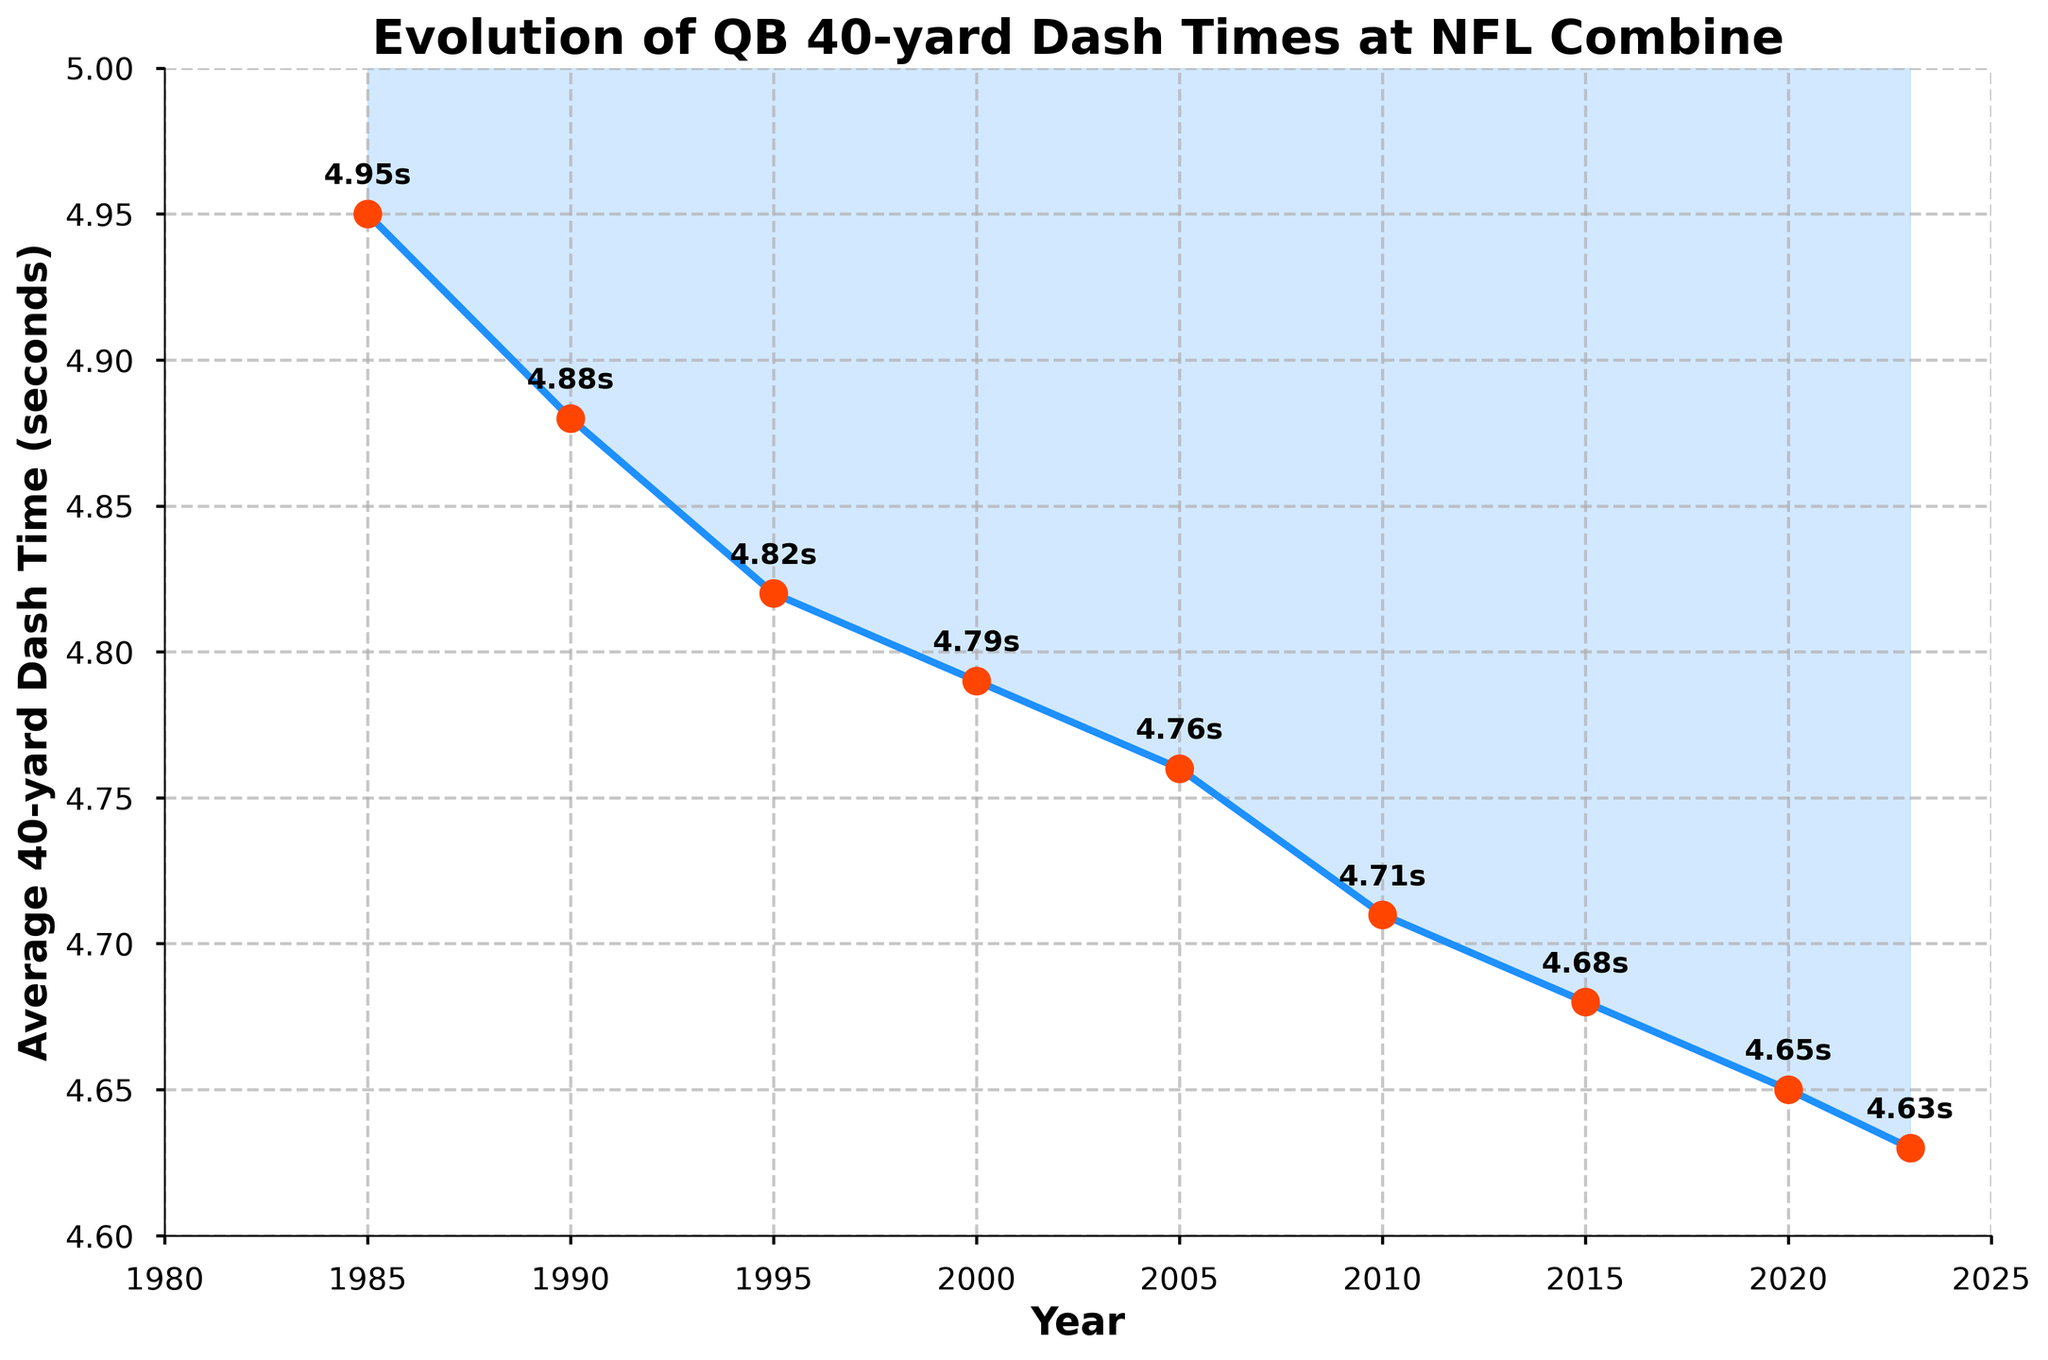What is the trend in quarterback 40-yard dash times from 1985 to 2023? Looking at the figure, the average 40-yard dash times have decreased from 4.95 seconds in 1985 to 4.63 seconds in 2023, indicating a gradual increase in speed over the years.
Answer: Decreasing trend Which year recorded the largest improvement in average 40-yard dash time compared to the previous recorded year? By examining the differences between consecutive years: 
1990-1985: 4.95-4.88 = 0.07 
1995-1990: 4.88-4.82 = 0.06 
2000-1995: 4.82-4.79 = 0.03 
2005-2000: 4.79-4.76 = 0.03 
2010-2005: 4.76-4.71 = 0.05 
2015-2010: 4.71-4.68 = 0.03 
2020-2015: 4.68-4.65 = 0.03 
2023-2020: 4.65-4.63 = 0.02 
So, the largest improvement was between 1985 and 1990 with a difference of 0.07 seconds.
Answer: 1990 How much faster were the quarterbacks on average in 2010 compared to 1985? By subtracting the 2010 time from the 1985 time: 4.95 - 4.71 = 0.24 seconds
Answer: 0.24 seconds What is the average (mean) of the average 40-yard dash times from all the years provided? Sum up all the dash times: 4.95 + 4.88 + 4.82 + 4.79 + 4.76 + 4.71 + 4.68 + 4.65 + 4.63 = 42.87, divide by the number of years, which is 9. 42.87 / 9 ≈ 4.763
Answer: 4.763 seconds In which time period did the average 40-yard dash times improve the most rapidly? From 1985 to 1995, the average times improved from 4.95 to 4.82, a 0.13-second improvement in 10 years (0.013 per year). From 1995 to 2023, they improved from 4.82 to 4.63, a 0.19-second improvement in 28 years (~0.0068 per year). That means the most rapid improvement was from 1985 to 1995.
Answer: 1985-1995 What is the difference in average 40-yard dash times between 1985 and 2023? Subtract the time in 2023 from the time in 1985: 4.95 - 4.63 = 0.32 seconds
Answer: 0.32 seconds Compare the average improvement in 40-yard dash times between the periods 2000-2010 and 2010-2020. Which period shows a greater average annual improvement? 1. Calculate the improvement for 2000-2010: 4.79 - 4.71 = 0.08 seconds over 10 years, 0.08/10 = 0.008 per year
2. Calculate the improvement for 2010-2020: 4.71 - 4.65 = 0.06 seconds over 10 years, 0.06/10 = 0.006 per year
Therefore, the period 2000-2010 shows a greater average annual improvement.
Answer: 2000-2010 In which year does the figure show the most significant drop in 40-yard dash times compared with the previous recorded year? By calculating the differences year by year we see that the biggest drop is from 1985 to 1990 (4.95 to 4.88), which is 0.07 seconds.
Answer: 1990 